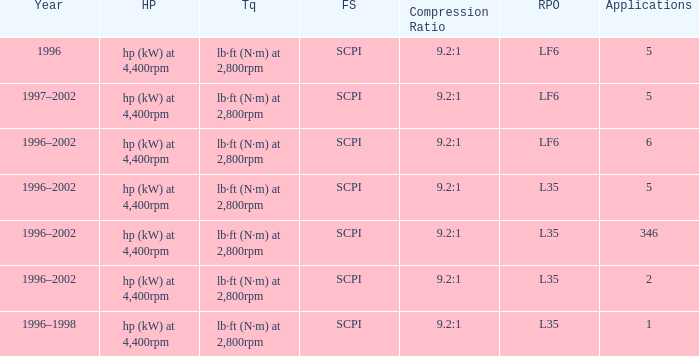What's the compression ratio of the model with L35 RPO and 5 applications? 9.2:1. Parse the full table. {'header': ['Year', 'HP', 'Tq', 'FS', 'Compression Ratio', 'RPO', 'Applications'], 'rows': [['1996', 'hp (kW) at 4,400rpm', 'lb·ft (N·m) at 2,800rpm', 'SCPI', '9.2:1', 'LF6', '5'], ['1997–2002', 'hp (kW) at 4,400rpm', 'lb·ft (N·m) at 2,800rpm', 'SCPI', '9.2:1', 'LF6', '5'], ['1996–2002', 'hp (kW) at 4,400rpm', 'lb·ft (N·m) at 2,800rpm', 'SCPI', '9.2:1', 'LF6', '6'], ['1996–2002', 'hp (kW) at 4,400rpm', 'lb·ft (N·m) at 2,800rpm', 'SCPI', '9.2:1', 'L35', '5'], ['1996–2002', 'hp (kW) at 4,400rpm', 'lb·ft (N·m) at 2,800rpm', 'SCPI', '9.2:1', 'L35', '346'], ['1996–2002', 'hp (kW) at 4,400rpm', 'lb·ft (N·m) at 2,800rpm', 'SCPI', '9.2:1', 'L35', '2'], ['1996–1998', 'hp (kW) at 4,400rpm', 'lb·ft (N·m) at 2,800rpm', 'SCPI', '9.2:1', 'L35', '1']]} 